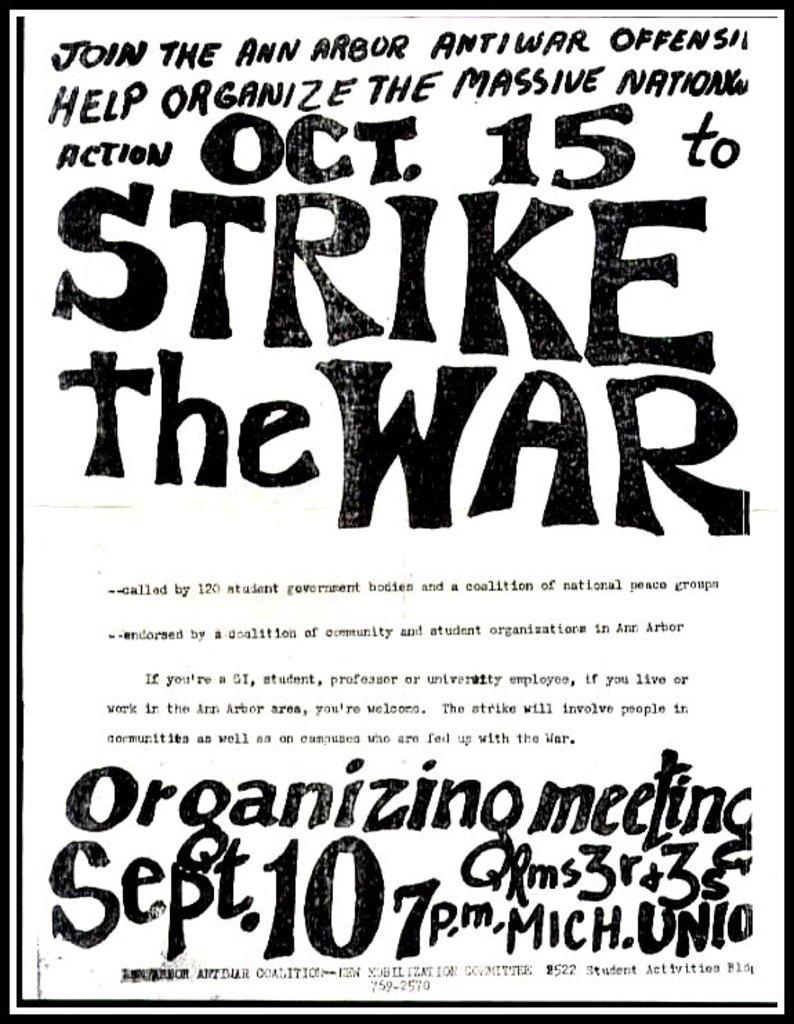What day in october is the strike?
Provide a short and direct response. 15. What date is the event in october?
Offer a terse response. 15. 